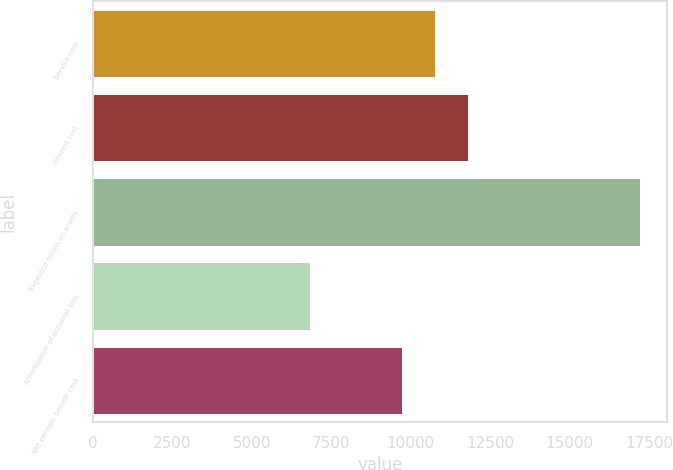<chart> <loc_0><loc_0><loc_500><loc_500><bar_chart><fcel>Service cost<fcel>Interest cost<fcel>Expected return on assets<fcel>Amortization of actuarial loss<fcel>Net periodic benefit cost<nl><fcel>10764.3<fcel>11800.6<fcel>17202<fcel>6839<fcel>9728<nl></chart> 